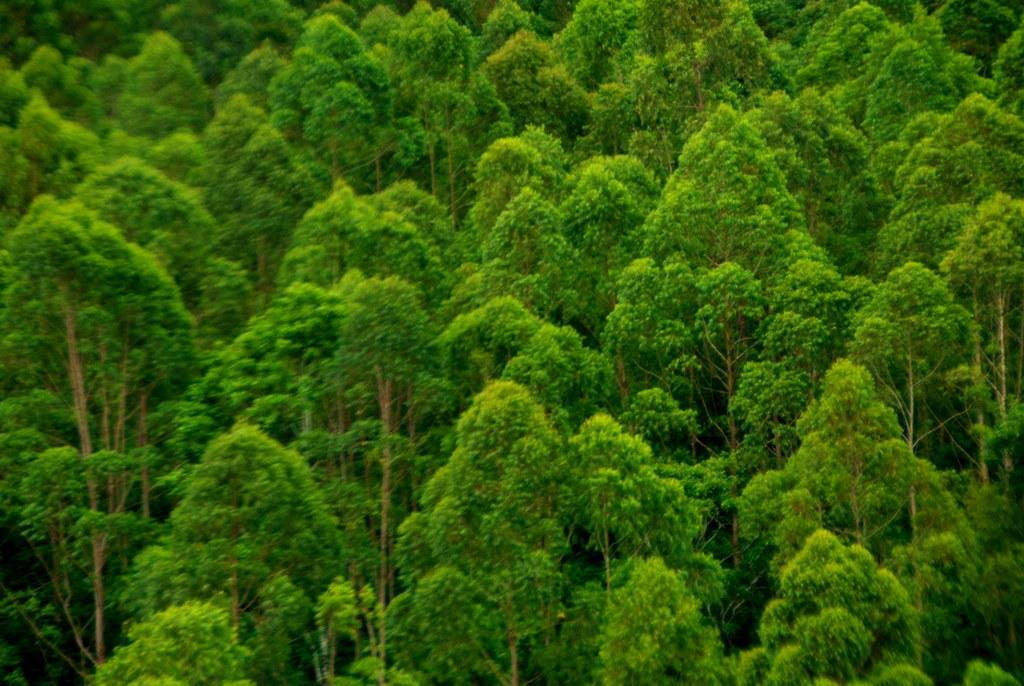What is the primary feature of the image? There are many trees in the image. Can you describe the setting of the image? The image features a natural setting with numerous trees. What type of vegetation is visible in the image? The image contains trees, which are a type of plant life. What type of feeling is the tree expressing in the image? Trees do not express feelings, as they are inanimate objects. What is the tree having for breakfast in the image? Trees do not eat breakfast, as they are not living beings that consume food. 